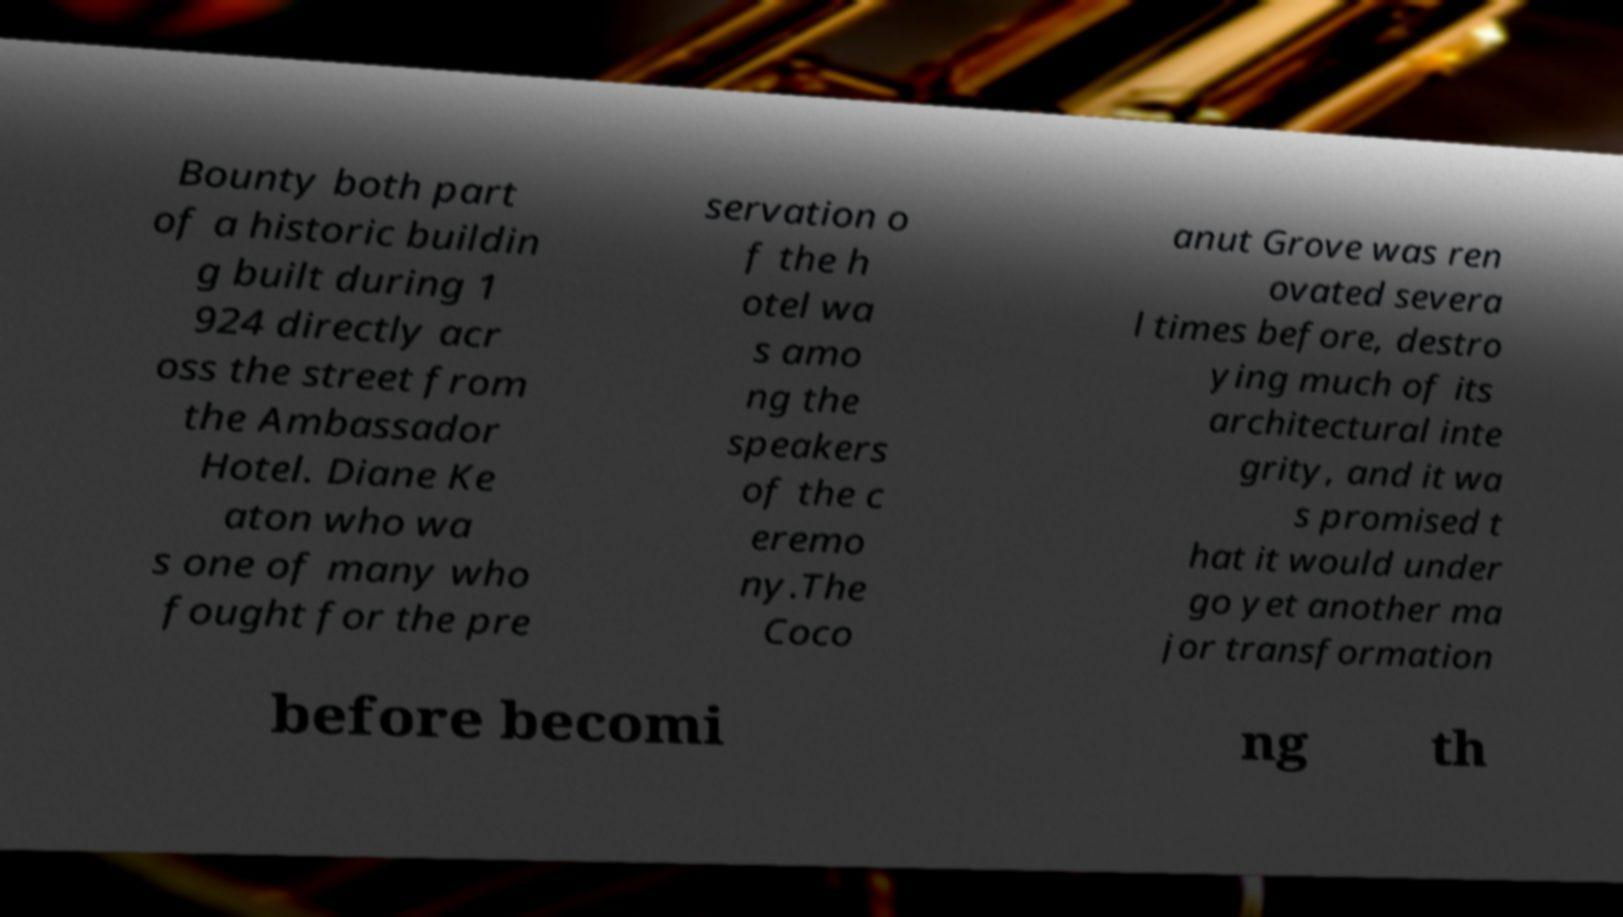Please read and relay the text visible in this image. What does it say? Bounty both part of a historic buildin g built during 1 924 directly acr oss the street from the Ambassador Hotel. Diane Ke aton who wa s one of many who fought for the pre servation o f the h otel wa s amo ng the speakers of the c eremo ny.The Coco anut Grove was ren ovated severa l times before, destro ying much of its architectural inte grity, and it wa s promised t hat it would under go yet another ma jor transformation before becomi ng th 